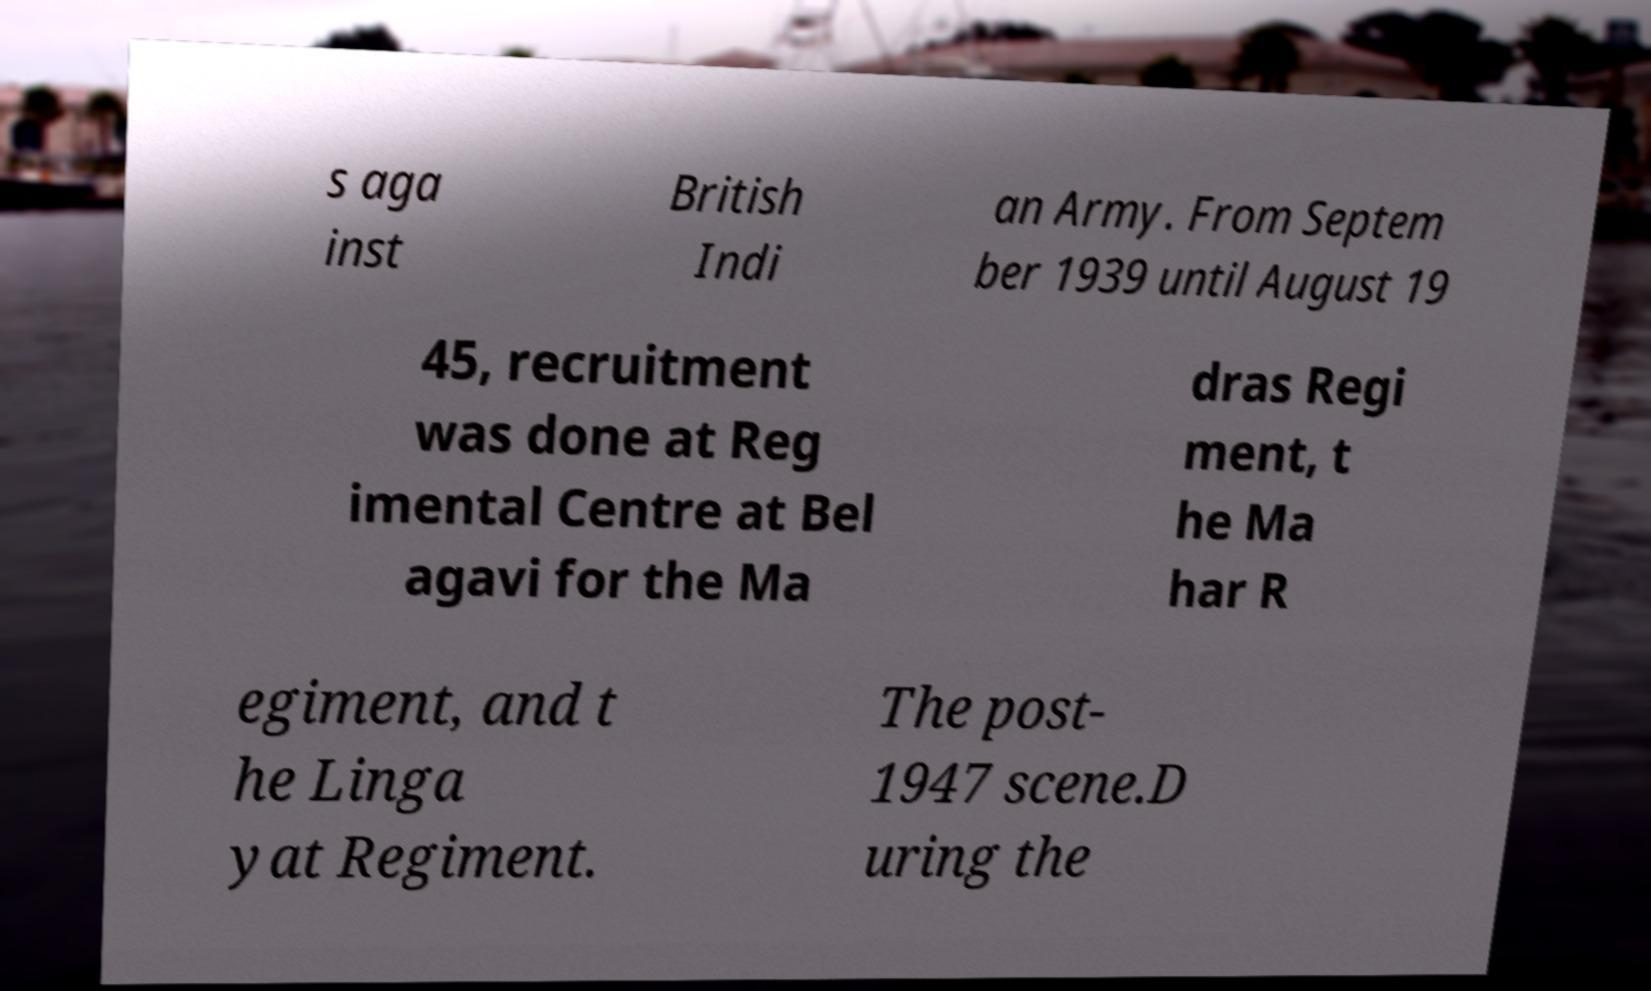Please identify and transcribe the text found in this image. s aga inst British Indi an Army. From Septem ber 1939 until August 19 45, recruitment was done at Reg imental Centre at Bel agavi for the Ma dras Regi ment, t he Ma har R egiment, and t he Linga yat Regiment. The post- 1947 scene.D uring the 